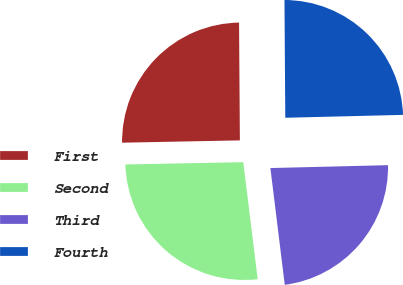Convert chart. <chart><loc_0><loc_0><loc_500><loc_500><pie_chart><fcel>First<fcel>Second<fcel>Third<fcel>Fourth<nl><fcel>25.2%<fcel>26.64%<fcel>23.44%<fcel>24.72%<nl></chart> 